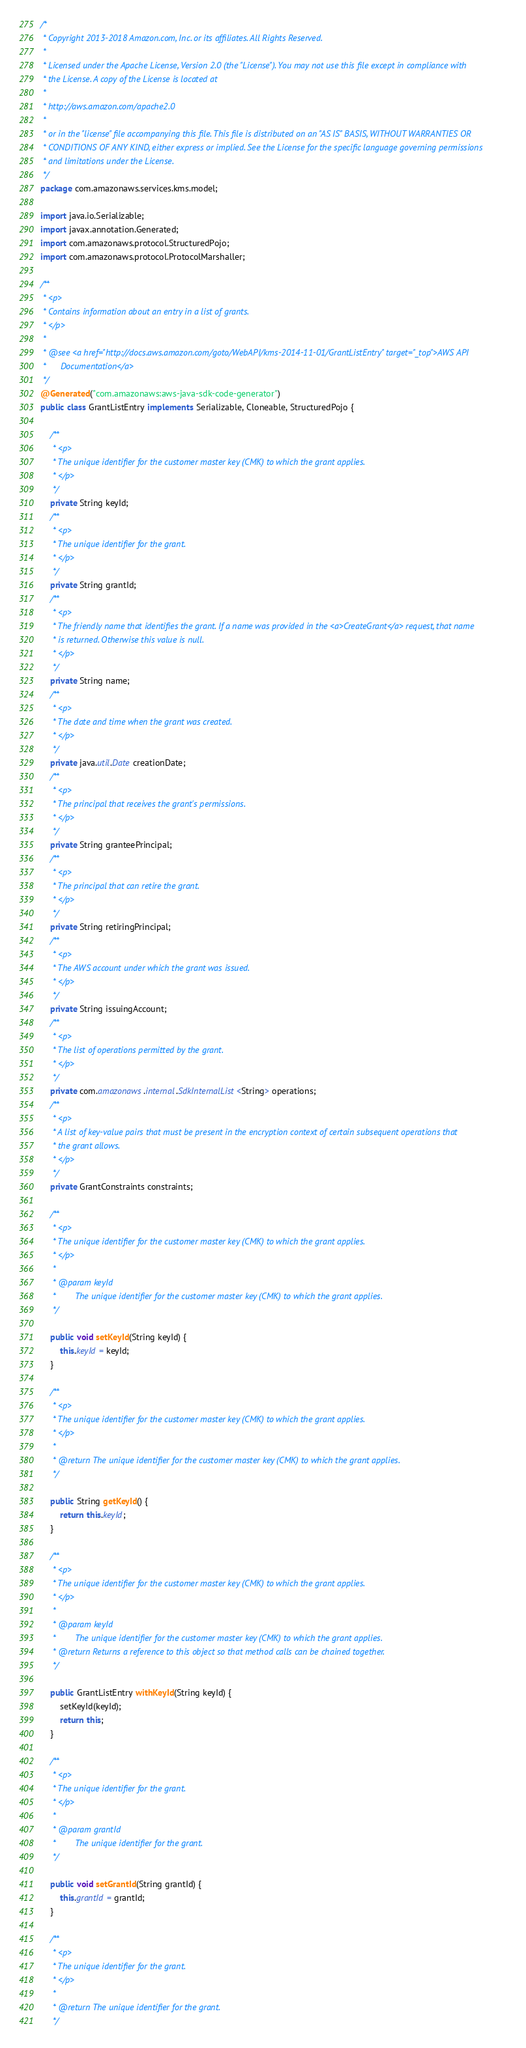<code> <loc_0><loc_0><loc_500><loc_500><_Java_>/*
 * Copyright 2013-2018 Amazon.com, Inc. or its affiliates. All Rights Reserved.
 * 
 * Licensed under the Apache License, Version 2.0 (the "License"). You may not use this file except in compliance with
 * the License. A copy of the License is located at
 * 
 * http://aws.amazon.com/apache2.0
 * 
 * or in the "license" file accompanying this file. This file is distributed on an "AS IS" BASIS, WITHOUT WARRANTIES OR
 * CONDITIONS OF ANY KIND, either express or implied. See the License for the specific language governing permissions
 * and limitations under the License.
 */
package com.amazonaws.services.kms.model;

import java.io.Serializable;
import javax.annotation.Generated;
import com.amazonaws.protocol.StructuredPojo;
import com.amazonaws.protocol.ProtocolMarshaller;

/**
 * <p>
 * Contains information about an entry in a list of grants.
 * </p>
 * 
 * @see <a href="http://docs.aws.amazon.com/goto/WebAPI/kms-2014-11-01/GrantListEntry" target="_top">AWS API
 *      Documentation</a>
 */
@Generated("com.amazonaws:aws-java-sdk-code-generator")
public class GrantListEntry implements Serializable, Cloneable, StructuredPojo {

    /**
     * <p>
     * The unique identifier for the customer master key (CMK) to which the grant applies.
     * </p>
     */
    private String keyId;
    /**
     * <p>
     * The unique identifier for the grant.
     * </p>
     */
    private String grantId;
    /**
     * <p>
     * The friendly name that identifies the grant. If a name was provided in the <a>CreateGrant</a> request, that name
     * is returned. Otherwise this value is null.
     * </p>
     */
    private String name;
    /**
     * <p>
     * The date and time when the grant was created.
     * </p>
     */
    private java.util.Date creationDate;
    /**
     * <p>
     * The principal that receives the grant's permissions.
     * </p>
     */
    private String granteePrincipal;
    /**
     * <p>
     * The principal that can retire the grant.
     * </p>
     */
    private String retiringPrincipal;
    /**
     * <p>
     * The AWS account under which the grant was issued.
     * </p>
     */
    private String issuingAccount;
    /**
     * <p>
     * The list of operations permitted by the grant.
     * </p>
     */
    private com.amazonaws.internal.SdkInternalList<String> operations;
    /**
     * <p>
     * A list of key-value pairs that must be present in the encryption context of certain subsequent operations that
     * the grant allows.
     * </p>
     */
    private GrantConstraints constraints;

    /**
     * <p>
     * The unique identifier for the customer master key (CMK) to which the grant applies.
     * </p>
     * 
     * @param keyId
     *        The unique identifier for the customer master key (CMK) to which the grant applies.
     */

    public void setKeyId(String keyId) {
        this.keyId = keyId;
    }

    /**
     * <p>
     * The unique identifier for the customer master key (CMK) to which the grant applies.
     * </p>
     * 
     * @return The unique identifier for the customer master key (CMK) to which the grant applies.
     */

    public String getKeyId() {
        return this.keyId;
    }

    /**
     * <p>
     * The unique identifier for the customer master key (CMK) to which the grant applies.
     * </p>
     * 
     * @param keyId
     *        The unique identifier for the customer master key (CMK) to which the grant applies.
     * @return Returns a reference to this object so that method calls can be chained together.
     */

    public GrantListEntry withKeyId(String keyId) {
        setKeyId(keyId);
        return this;
    }

    /**
     * <p>
     * The unique identifier for the grant.
     * </p>
     * 
     * @param grantId
     *        The unique identifier for the grant.
     */

    public void setGrantId(String grantId) {
        this.grantId = grantId;
    }

    /**
     * <p>
     * The unique identifier for the grant.
     * </p>
     * 
     * @return The unique identifier for the grant.
     */
</code> 